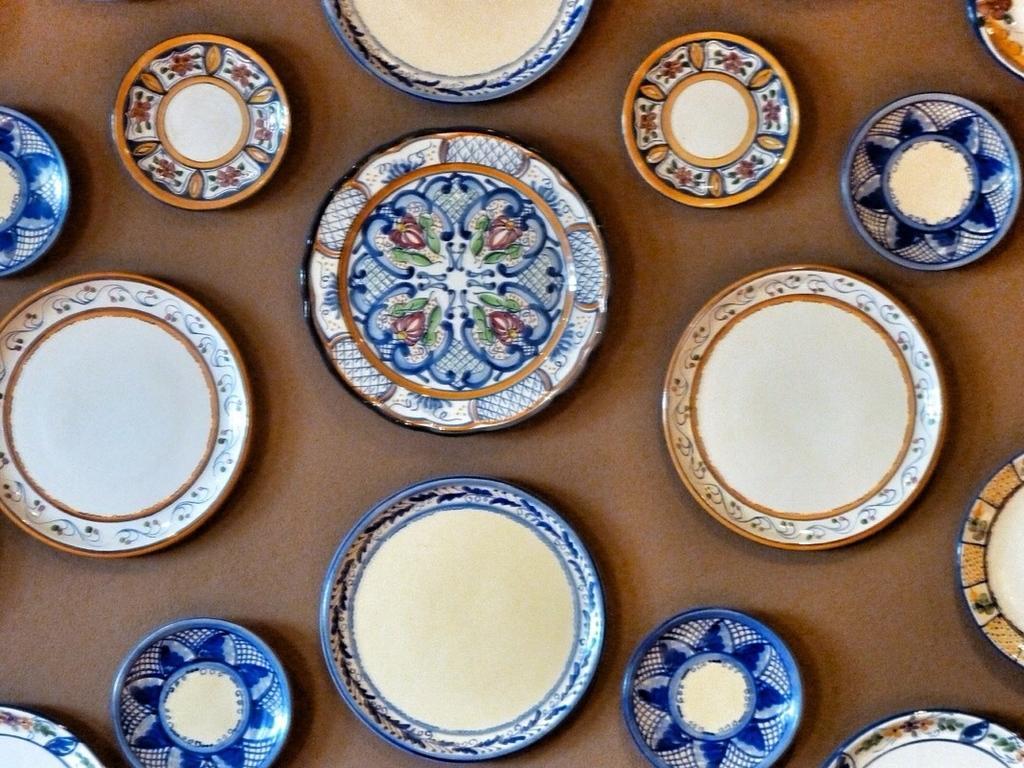How would you summarize this image in a sentence or two? In the foreground of this image, there are many platters on brown surface. 